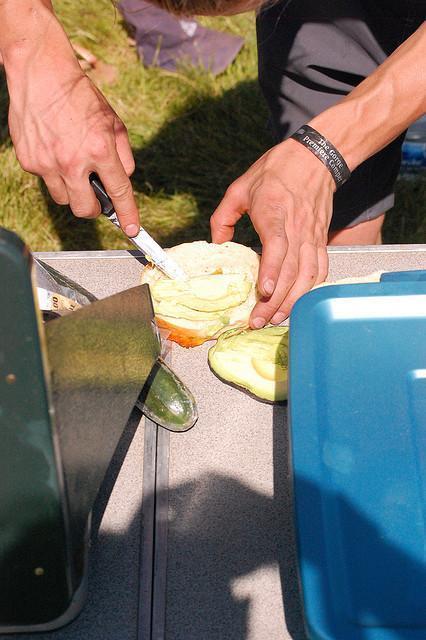How many sandwiches are in the picture?
Give a very brief answer. 1. 